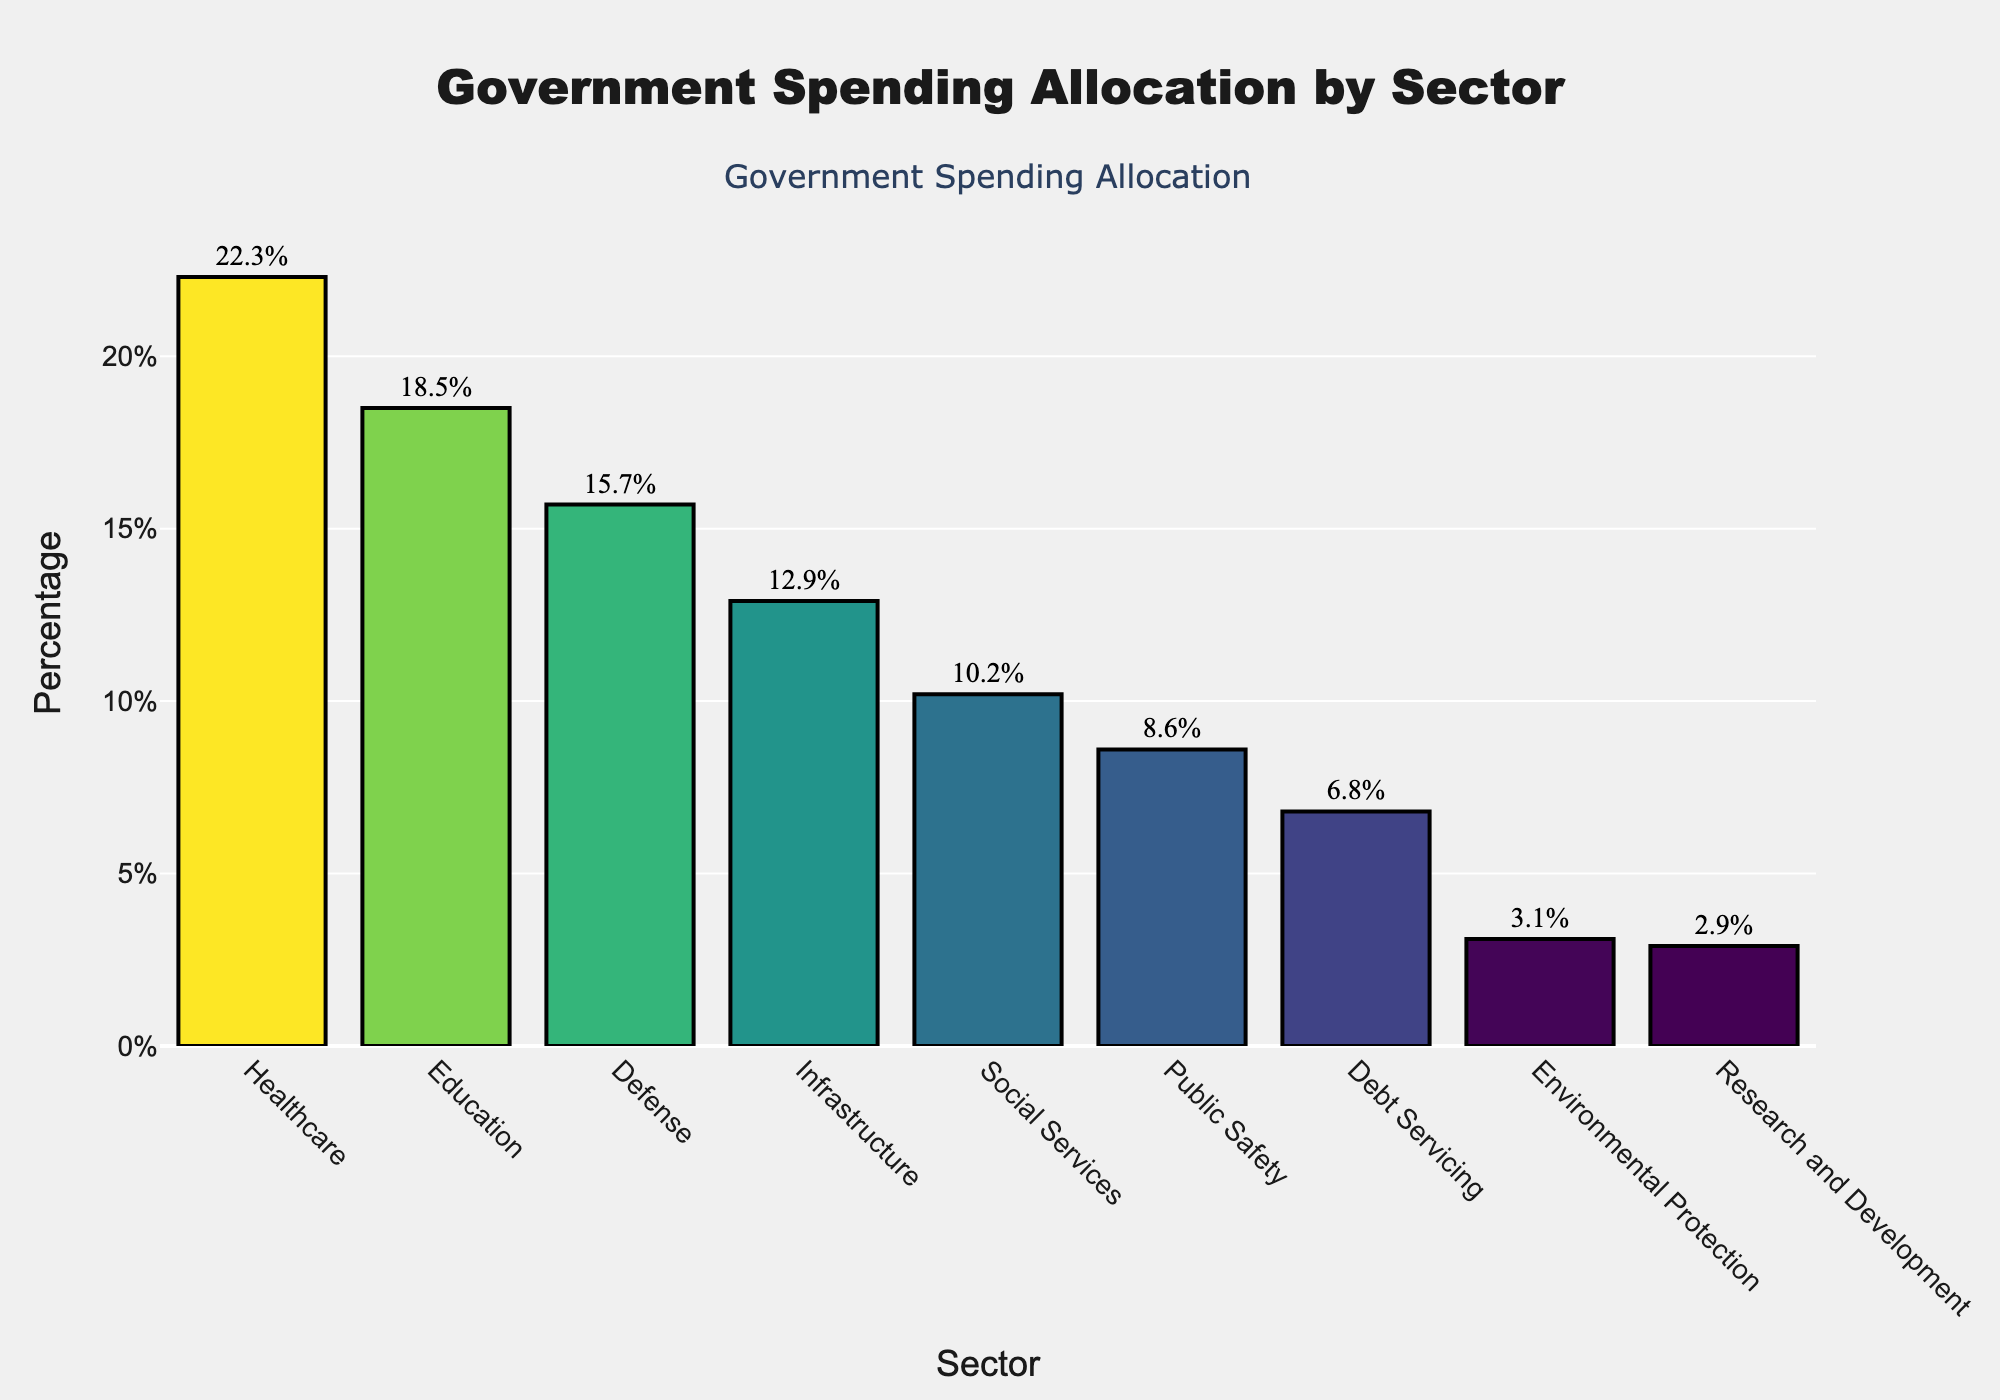what is the total percentage of spending on Education and Healthcare? Add the percentages for Education (18.5%) and Healthcare (22.3%). 18.5 + 22.3 = 40.8
Answer: 40.8% Which sector receives the lowest allocation? Identify the sector with the smallest percentage. Research and Development has the lowest value at 2.9%.
Answer: Research and Development Is the spending on Defense greater or less than that on Infrastructure? Compare the percentages for Defense (15.7%) and Infrastructure (12.9%). 15.7 > 12.9, so Defense is greater.
Answer: Greater What is the difference in percentage points between Public Safety and Research and Development? Subtract the smaller percentage (Research and Development, 2.9%) from the larger one (Public Safety, 8.6%). 8.6 - 2.9 = 5.7
Answer: 5.7 How much more is spent on Healthcare than on Defense? Subtract the percentage for Defense (15.7%) from the percentage for Healthcare (22.3%). 22.3 - 15.7 = 6.6
Answer: 6.6 Which sector gets the third-highest allocation of funds? Sort the percentages in descending order: Healthcare (22.3%), Education (18.5%), Defense (15.7%). Defense is the third-highest.
Answer: Defense What's the percentage difference between the sectors with the highest and lowest spending? Subtract the smallest percentage (Research and Development, 2.9%) from the largest percentage (Healthcare, 22.3%). 22.3 - 2.9 = 19.4
Answer: 19.4 Which sectors have spending allocations greater than 10%? List sectors whose percentages exceed 10%: Healthcare (22.3%), Education (18.5%), Defense (15.7%), and Infrastructure (12.9%).
Answer: Healthcare, Education, Defense, Infrastructure Are there any sectors with spending allocations below 5%? Identify sectors with percentages less than 5%. Environmental Protection (3.1%) and Research and Development (2.9%) are both below 5%.
Answer: Environmental Protection, Research and Development What's the combined spending allocation for Social Services, Public Safety, and Debt Servicing? Add percentages for Social Services (10.2%), Public Safety (8.6%), and Debt Servicing (6.8%). 10.2 + 8.6 + 6.8 = 25.6
Answer: 25.6 